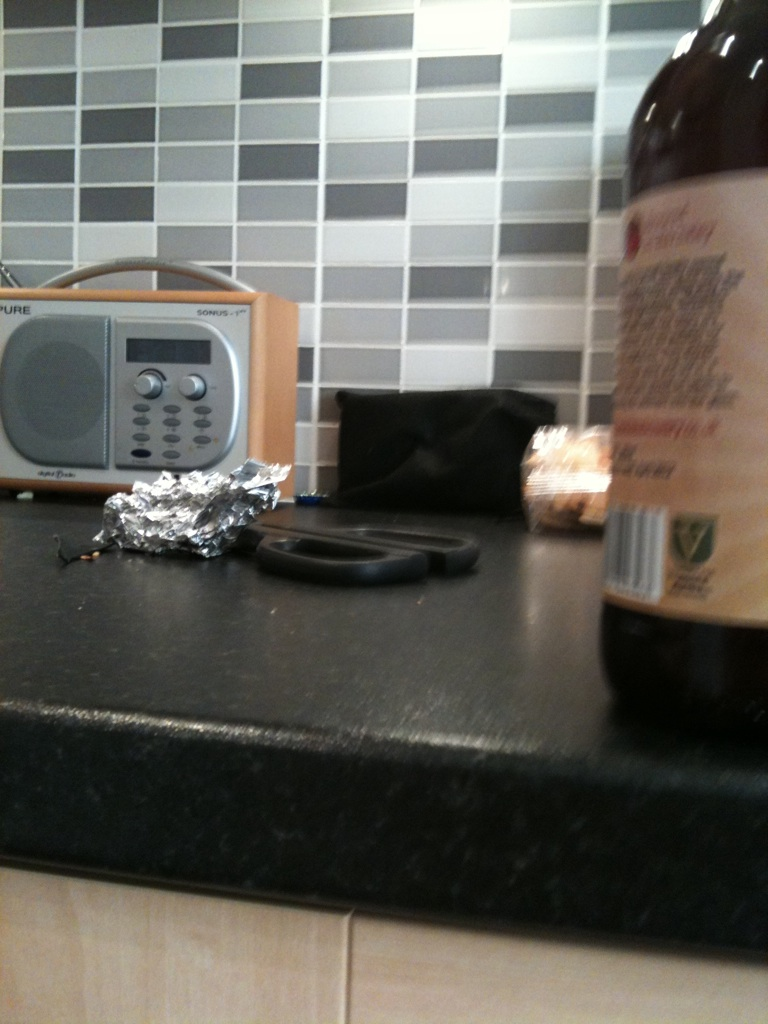Can you create a story around this kitchen counter? In a cozy suburban home, the kitchen is where family memories unfold. Each morning, the aroma of freshly brewed coffee fills the air, mingling with the sound of the radio as it cheerfully broadcasts the day’s news. The kitchen counter is a hub of activity; the radio has been in the family for years, providing a nostalgic soundtrack to their lives. The scissors and foil see frequent use as Mom packs lunches for school, Dad preps ingredients for dinner, and the kids eagerly unwrap their treats. This hearty, beloved kitchen counter stands as a testament to the simple joys and routines that knit this family together. 